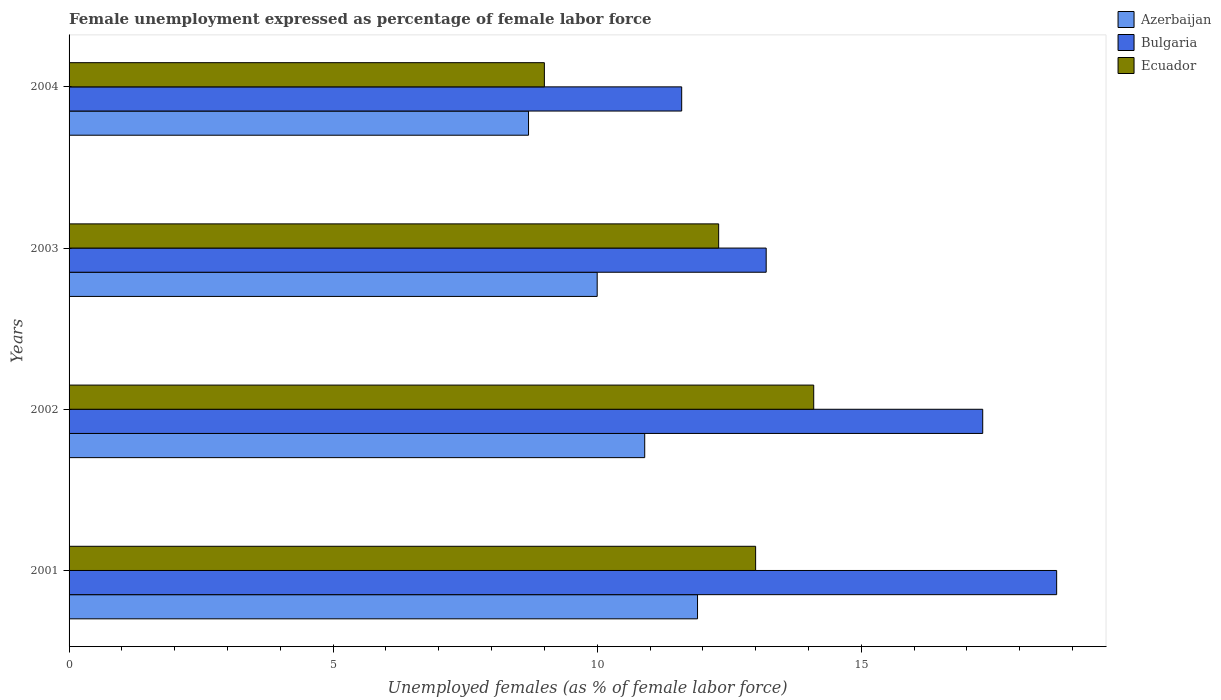How many different coloured bars are there?
Provide a succinct answer. 3. How many groups of bars are there?
Give a very brief answer. 4. How many bars are there on the 2nd tick from the top?
Give a very brief answer. 3. What is the label of the 2nd group of bars from the top?
Your answer should be very brief. 2003. Across all years, what is the maximum unemployment in females in in Ecuador?
Give a very brief answer. 14.1. Across all years, what is the minimum unemployment in females in in Ecuador?
Give a very brief answer. 9. In which year was the unemployment in females in in Ecuador maximum?
Make the answer very short. 2002. In which year was the unemployment in females in in Bulgaria minimum?
Your answer should be compact. 2004. What is the total unemployment in females in in Azerbaijan in the graph?
Offer a terse response. 41.5. What is the difference between the unemployment in females in in Ecuador in 2001 and that in 2002?
Your response must be concise. -1.1. What is the difference between the unemployment in females in in Ecuador in 2004 and the unemployment in females in in Azerbaijan in 2002?
Keep it short and to the point. -1.9. What is the average unemployment in females in in Azerbaijan per year?
Ensure brevity in your answer.  10.37. In the year 2002, what is the difference between the unemployment in females in in Ecuador and unemployment in females in in Azerbaijan?
Keep it short and to the point. 3.2. In how many years, is the unemployment in females in in Azerbaijan greater than 7 %?
Keep it short and to the point. 4. What is the ratio of the unemployment in females in in Azerbaijan in 2001 to that in 2003?
Your response must be concise. 1.19. Is the unemployment in females in in Ecuador in 2003 less than that in 2004?
Make the answer very short. No. Is the difference between the unemployment in females in in Ecuador in 2002 and 2003 greater than the difference between the unemployment in females in in Azerbaijan in 2002 and 2003?
Provide a short and direct response. Yes. What is the difference between the highest and the second highest unemployment in females in in Ecuador?
Offer a very short reply. 1.1. What is the difference between the highest and the lowest unemployment in females in in Bulgaria?
Offer a very short reply. 7.1. In how many years, is the unemployment in females in in Azerbaijan greater than the average unemployment in females in in Azerbaijan taken over all years?
Your response must be concise. 2. What does the 1st bar from the top in 2002 represents?
Provide a succinct answer. Ecuador. What does the 1st bar from the bottom in 2001 represents?
Your answer should be very brief. Azerbaijan. Are the values on the major ticks of X-axis written in scientific E-notation?
Ensure brevity in your answer.  No. What is the title of the graph?
Your answer should be compact. Female unemployment expressed as percentage of female labor force. What is the label or title of the X-axis?
Give a very brief answer. Unemployed females (as % of female labor force). What is the Unemployed females (as % of female labor force) in Azerbaijan in 2001?
Your answer should be very brief. 11.9. What is the Unemployed females (as % of female labor force) of Bulgaria in 2001?
Give a very brief answer. 18.7. What is the Unemployed females (as % of female labor force) of Ecuador in 2001?
Offer a terse response. 13. What is the Unemployed females (as % of female labor force) of Azerbaijan in 2002?
Offer a terse response. 10.9. What is the Unemployed females (as % of female labor force) in Bulgaria in 2002?
Your response must be concise. 17.3. What is the Unemployed females (as % of female labor force) in Ecuador in 2002?
Give a very brief answer. 14.1. What is the Unemployed females (as % of female labor force) in Azerbaijan in 2003?
Offer a very short reply. 10. What is the Unemployed females (as % of female labor force) of Bulgaria in 2003?
Your answer should be very brief. 13.2. What is the Unemployed females (as % of female labor force) of Ecuador in 2003?
Provide a succinct answer. 12.3. What is the Unemployed females (as % of female labor force) in Azerbaijan in 2004?
Offer a terse response. 8.7. What is the Unemployed females (as % of female labor force) of Bulgaria in 2004?
Offer a terse response. 11.6. What is the Unemployed females (as % of female labor force) in Ecuador in 2004?
Ensure brevity in your answer.  9. Across all years, what is the maximum Unemployed females (as % of female labor force) in Azerbaijan?
Provide a short and direct response. 11.9. Across all years, what is the maximum Unemployed females (as % of female labor force) in Bulgaria?
Make the answer very short. 18.7. Across all years, what is the maximum Unemployed females (as % of female labor force) of Ecuador?
Ensure brevity in your answer.  14.1. Across all years, what is the minimum Unemployed females (as % of female labor force) of Azerbaijan?
Make the answer very short. 8.7. Across all years, what is the minimum Unemployed females (as % of female labor force) in Bulgaria?
Make the answer very short. 11.6. Across all years, what is the minimum Unemployed females (as % of female labor force) in Ecuador?
Provide a short and direct response. 9. What is the total Unemployed females (as % of female labor force) in Azerbaijan in the graph?
Keep it short and to the point. 41.5. What is the total Unemployed females (as % of female labor force) in Bulgaria in the graph?
Your response must be concise. 60.8. What is the total Unemployed females (as % of female labor force) of Ecuador in the graph?
Offer a very short reply. 48.4. What is the difference between the Unemployed females (as % of female labor force) of Azerbaijan in 2001 and that in 2003?
Keep it short and to the point. 1.9. What is the difference between the Unemployed females (as % of female labor force) of Azerbaijan in 2002 and that in 2003?
Your answer should be very brief. 0.9. What is the difference between the Unemployed females (as % of female labor force) of Ecuador in 2002 and that in 2003?
Your answer should be very brief. 1.8. What is the difference between the Unemployed females (as % of female labor force) in Azerbaijan in 2002 and that in 2004?
Your answer should be compact. 2.2. What is the difference between the Unemployed females (as % of female labor force) in Bulgaria in 2002 and that in 2004?
Offer a very short reply. 5.7. What is the difference between the Unemployed females (as % of female labor force) of Azerbaijan in 2003 and that in 2004?
Provide a succinct answer. 1.3. What is the difference between the Unemployed females (as % of female labor force) of Ecuador in 2003 and that in 2004?
Your answer should be very brief. 3.3. What is the difference between the Unemployed females (as % of female labor force) in Azerbaijan in 2001 and the Unemployed females (as % of female labor force) in Bulgaria in 2002?
Your answer should be very brief. -5.4. What is the difference between the Unemployed females (as % of female labor force) in Azerbaijan in 2001 and the Unemployed females (as % of female labor force) in Ecuador in 2002?
Offer a very short reply. -2.2. What is the difference between the Unemployed females (as % of female labor force) in Azerbaijan in 2001 and the Unemployed females (as % of female labor force) in Bulgaria in 2003?
Offer a terse response. -1.3. What is the difference between the Unemployed females (as % of female labor force) in Azerbaijan in 2002 and the Unemployed females (as % of female labor force) in Bulgaria in 2003?
Your response must be concise. -2.3. What is the difference between the Unemployed females (as % of female labor force) of Azerbaijan in 2002 and the Unemployed females (as % of female labor force) of Ecuador in 2004?
Offer a very short reply. 1.9. What is the difference between the Unemployed females (as % of female labor force) in Azerbaijan in 2003 and the Unemployed females (as % of female labor force) in Bulgaria in 2004?
Offer a terse response. -1.6. What is the difference between the Unemployed females (as % of female labor force) of Azerbaijan in 2003 and the Unemployed females (as % of female labor force) of Ecuador in 2004?
Give a very brief answer. 1. What is the average Unemployed females (as % of female labor force) in Azerbaijan per year?
Offer a terse response. 10.38. What is the average Unemployed females (as % of female labor force) in Ecuador per year?
Ensure brevity in your answer.  12.1. In the year 2001, what is the difference between the Unemployed females (as % of female labor force) of Azerbaijan and Unemployed females (as % of female labor force) of Bulgaria?
Offer a very short reply. -6.8. In the year 2001, what is the difference between the Unemployed females (as % of female labor force) in Bulgaria and Unemployed females (as % of female labor force) in Ecuador?
Offer a very short reply. 5.7. In the year 2003, what is the difference between the Unemployed females (as % of female labor force) of Azerbaijan and Unemployed females (as % of female labor force) of Ecuador?
Keep it short and to the point. -2.3. In the year 2004, what is the difference between the Unemployed females (as % of female labor force) in Azerbaijan and Unemployed females (as % of female labor force) in Ecuador?
Your response must be concise. -0.3. What is the ratio of the Unemployed females (as % of female labor force) in Azerbaijan in 2001 to that in 2002?
Provide a succinct answer. 1.09. What is the ratio of the Unemployed females (as % of female labor force) in Bulgaria in 2001 to that in 2002?
Provide a short and direct response. 1.08. What is the ratio of the Unemployed females (as % of female labor force) in Ecuador in 2001 to that in 2002?
Your answer should be compact. 0.92. What is the ratio of the Unemployed females (as % of female labor force) of Azerbaijan in 2001 to that in 2003?
Keep it short and to the point. 1.19. What is the ratio of the Unemployed females (as % of female labor force) in Bulgaria in 2001 to that in 2003?
Your answer should be very brief. 1.42. What is the ratio of the Unemployed females (as % of female labor force) in Ecuador in 2001 to that in 2003?
Offer a very short reply. 1.06. What is the ratio of the Unemployed females (as % of female labor force) in Azerbaijan in 2001 to that in 2004?
Ensure brevity in your answer.  1.37. What is the ratio of the Unemployed females (as % of female labor force) in Bulgaria in 2001 to that in 2004?
Ensure brevity in your answer.  1.61. What is the ratio of the Unemployed females (as % of female labor force) of Ecuador in 2001 to that in 2004?
Offer a terse response. 1.44. What is the ratio of the Unemployed females (as % of female labor force) of Azerbaijan in 2002 to that in 2003?
Offer a terse response. 1.09. What is the ratio of the Unemployed females (as % of female labor force) of Bulgaria in 2002 to that in 2003?
Offer a terse response. 1.31. What is the ratio of the Unemployed females (as % of female labor force) in Ecuador in 2002 to that in 2003?
Keep it short and to the point. 1.15. What is the ratio of the Unemployed females (as % of female labor force) of Azerbaijan in 2002 to that in 2004?
Make the answer very short. 1.25. What is the ratio of the Unemployed females (as % of female labor force) of Bulgaria in 2002 to that in 2004?
Provide a succinct answer. 1.49. What is the ratio of the Unemployed females (as % of female labor force) of Ecuador in 2002 to that in 2004?
Your answer should be very brief. 1.57. What is the ratio of the Unemployed females (as % of female labor force) in Azerbaijan in 2003 to that in 2004?
Your answer should be very brief. 1.15. What is the ratio of the Unemployed females (as % of female labor force) in Bulgaria in 2003 to that in 2004?
Offer a very short reply. 1.14. What is the ratio of the Unemployed females (as % of female labor force) of Ecuador in 2003 to that in 2004?
Your answer should be compact. 1.37. What is the difference between the highest and the second highest Unemployed females (as % of female labor force) of Azerbaijan?
Offer a very short reply. 1. What is the difference between the highest and the second highest Unemployed females (as % of female labor force) of Bulgaria?
Your answer should be compact. 1.4. What is the difference between the highest and the lowest Unemployed females (as % of female labor force) in Azerbaijan?
Your answer should be very brief. 3.2. 